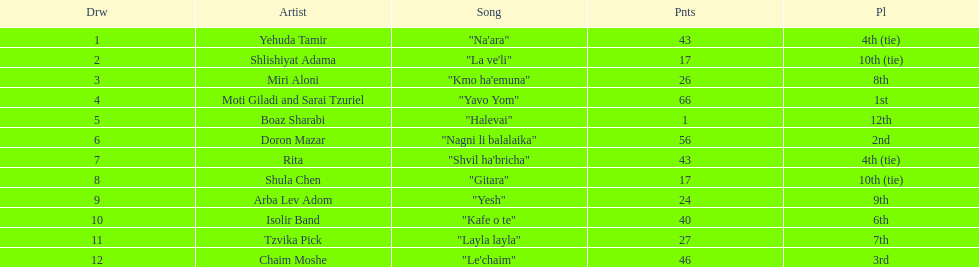Did the song "gitara" or "yesh" earn more points? "Yesh". 